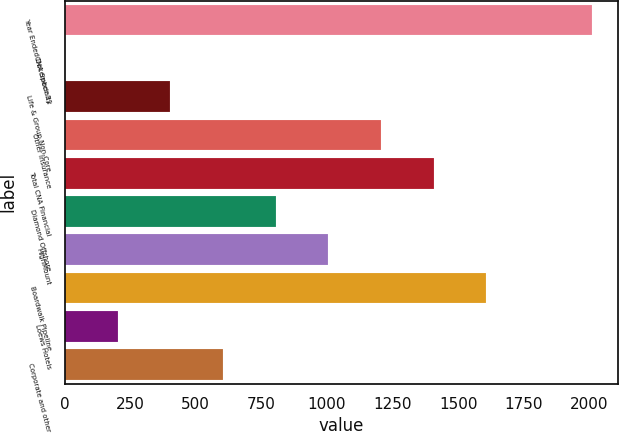<chart> <loc_0><loc_0><loc_500><loc_500><bar_chart><fcel>Year Ended December 31<fcel>CNA Specialty<fcel>Life & Group Non-Core<fcel>Other Insurance<fcel>Total CNA Financial<fcel>Diamond Offshore<fcel>HighMount<fcel>Boardwalk Pipeline<fcel>Loews Hotels<fcel>Corporate and other<nl><fcel>2009<fcel>1<fcel>402.6<fcel>1205.8<fcel>1406.6<fcel>804.2<fcel>1005<fcel>1607.4<fcel>201.8<fcel>603.4<nl></chart> 